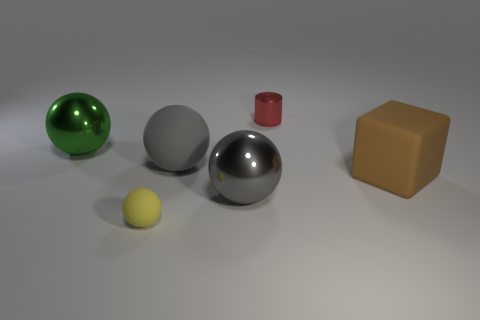Are the large green thing and the tiny object that is in front of the big green thing made of the same material?
Ensure brevity in your answer.  No. What is the material of the small cylinder to the right of the large green ball?
Give a very brief answer. Metal. The gray metal thing is what size?
Your answer should be compact. Large. There is a cylinder that is behind the yellow matte ball; is its size the same as the matte thing behind the brown cube?
Your answer should be compact. No. What size is the gray metallic object that is the same shape as the small yellow object?
Your response must be concise. Large. Do the green thing and the thing that is to the right of the red thing have the same size?
Your response must be concise. Yes. Is there a gray matte ball to the left of the rubber object on the right side of the gray shiny thing?
Provide a short and direct response. Yes. The tiny object that is on the left side of the tiny red metallic cylinder has what shape?
Give a very brief answer. Sphere. There is another big ball that is the same color as the big rubber sphere; what material is it?
Offer a terse response. Metal. There is a small thing that is left of the thing behind the green shiny ball; what is its color?
Give a very brief answer. Yellow. 